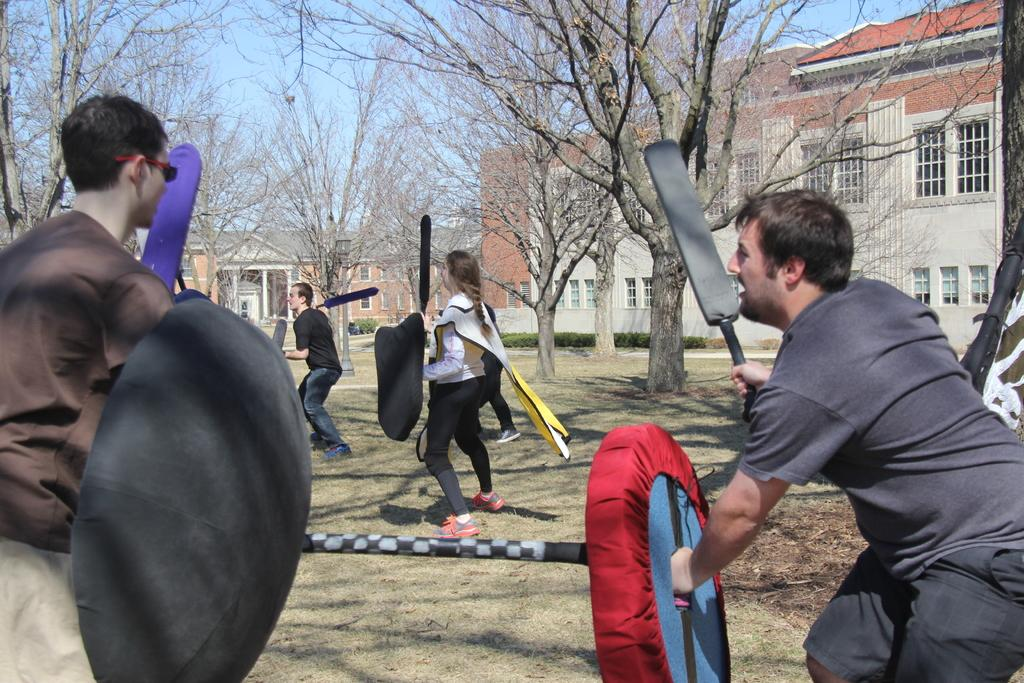Who or what is present in the image? There are people in the image. What are the people holding in their hands? The people are holding bats and shields. What can be seen in the background of the image? There are trees and buildings in the background of the image. What type of manager is present in the image? There is no manager present in the image. Is there a birthday celebration happening in the image? There is no indication of a birthday celebration in the image. 